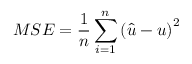Convert formula to latex. <formula><loc_0><loc_0><loc_500><loc_500>M S E = \frac { 1 } { n } \sum _ { i = 1 } ^ { n } { { { \left ( { \hat { u } - u } \right ) } ^ { 2 } } }</formula> 